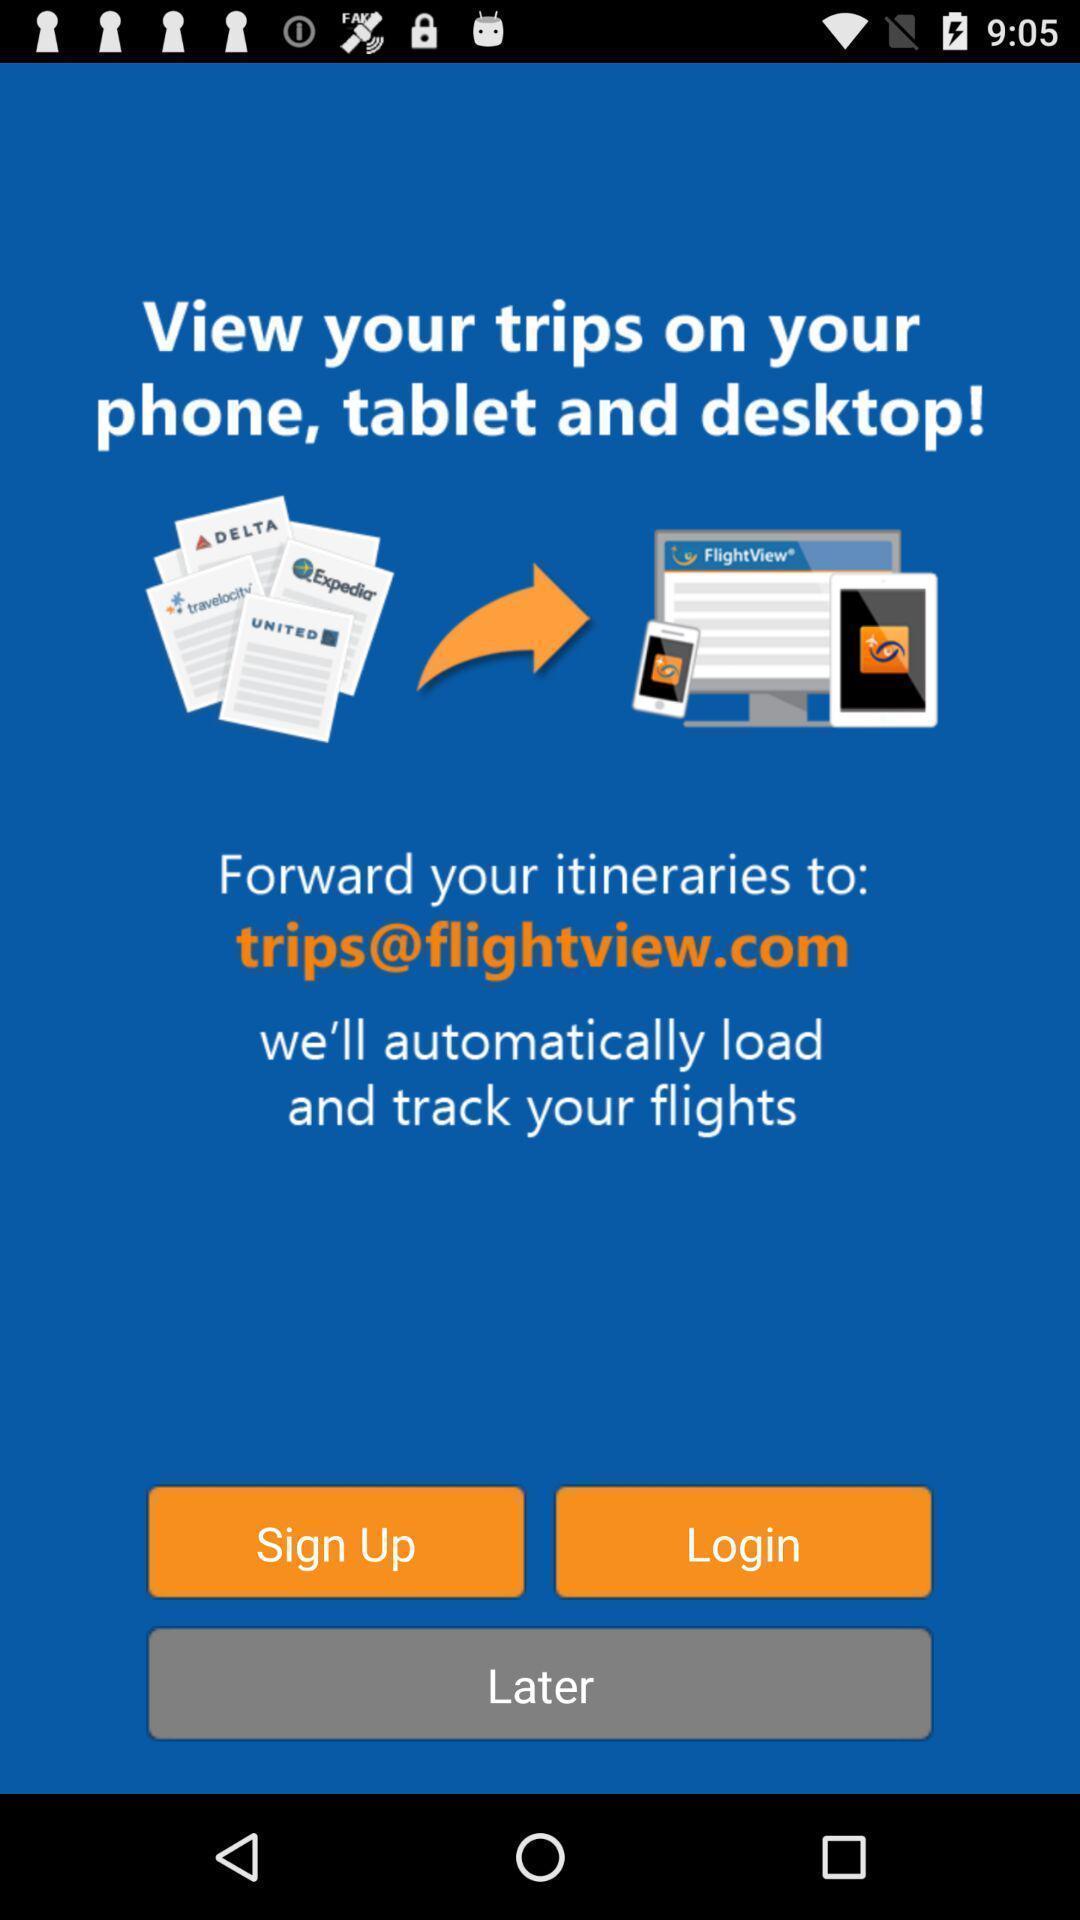Please provide a description for this image. Sign up or login page for a social app. 